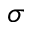<formula> <loc_0><loc_0><loc_500><loc_500>\sigma</formula> 